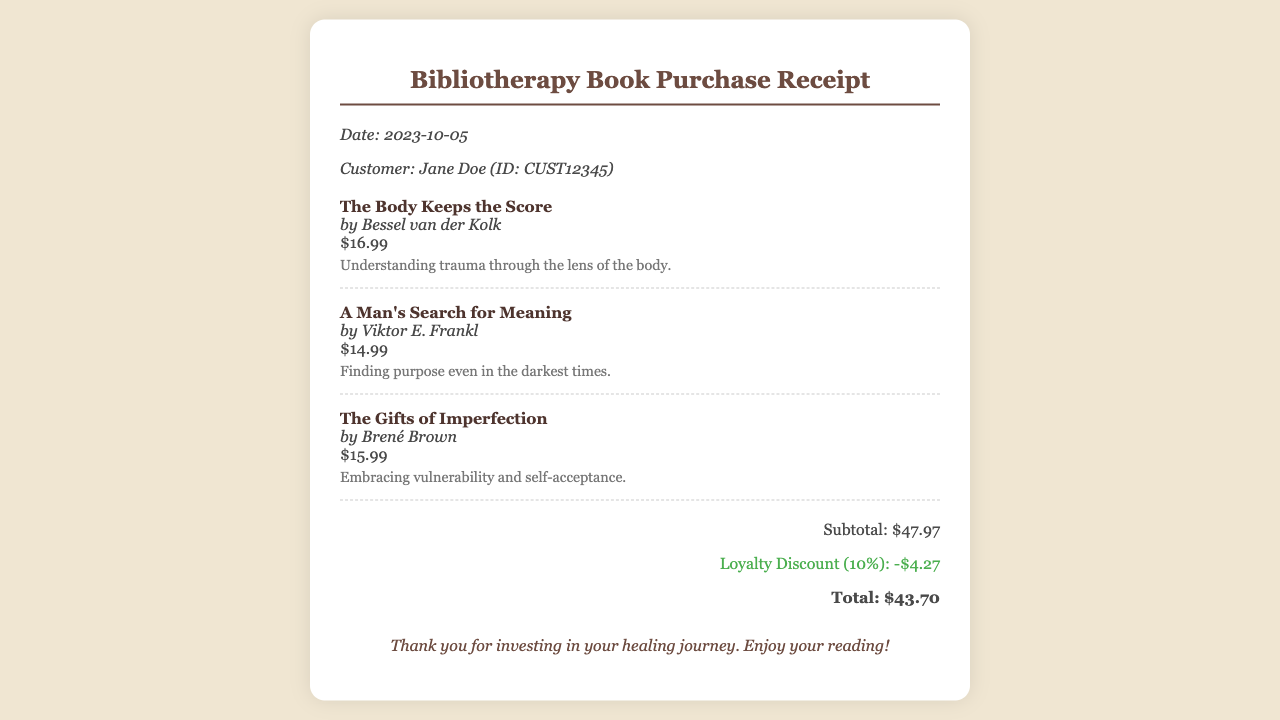What is the date of purchase? The date of purchase is specifically mentioned in the document.
Answer: 2023-10-05 Who is the customer? The receipt includes the name of the customer along with their ID.
Answer: Jane Doe (ID: CUST12345) What is the price of "The Body Keeps the Score"? The individual book prices are listed in the document.
Answer: $16.99 What is the loyalty discount applied? The receipt states the amount discounted for loyalty customers.
Answer: -$4.27 What is the total amount after discount? The total includes the subtotal minus the loyalty discount.
Answer: $43.70 Which book is authored by Bessel van der Kolk? The document mentions book titles along with their corresponding authors.
Answer: The Body Keeps the Score What is the subtotal before applying discounts? The subtotal is explicitly stated in the receipt.
Answer: $47.97 What theme does "The Gifts of Imperfection" focus on? Each book has a brief note describing its theme in the receipt.
Answer: Embracing vulnerability and self-acceptance How many novels are listed in the purchase? The document indicates the number of book items purchased.
Answer: 3 